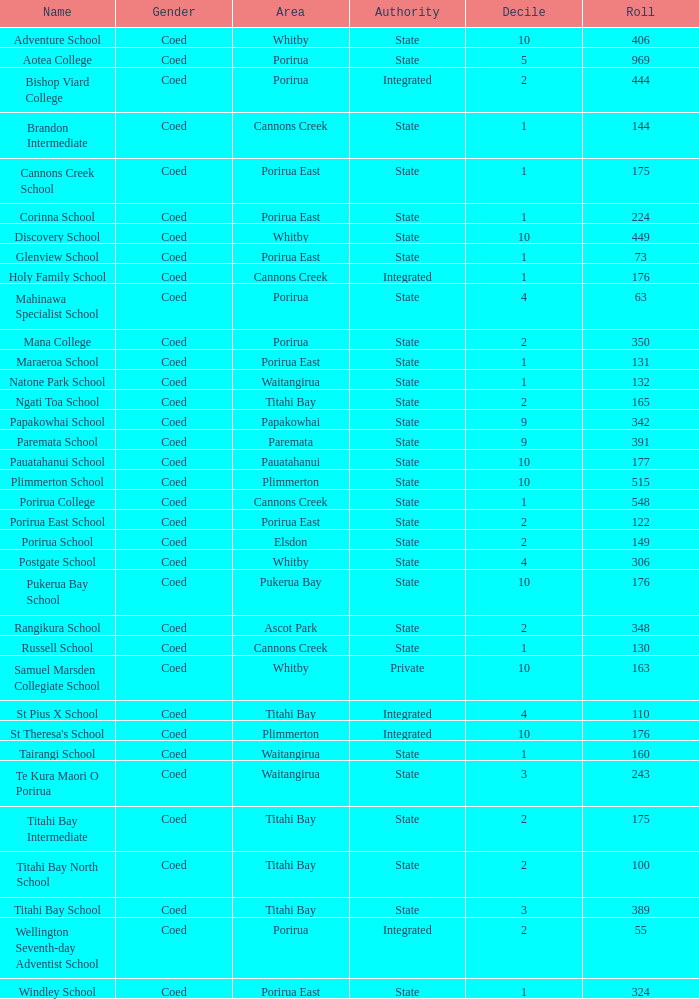Which combined school had a decile rating of 2 and an enrollment of over 55 students? Bishop Viard College. Could you help me parse every detail presented in this table? {'header': ['Name', 'Gender', 'Area', 'Authority', 'Decile', 'Roll'], 'rows': [['Adventure School', 'Coed', 'Whitby', 'State', '10', '406'], ['Aotea College', 'Coed', 'Porirua', 'State', '5', '969'], ['Bishop Viard College', 'Coed', 'Porirua', 'Integrated', '2', '444'], ['Brandon Intermediate', 'Coed', 'Cannons Creek', 'State', '1', '144'], ['Cannons Creek School', 'Coed', 'Porirua East', 'State', '1', '175'], ['Corinna School', 'Coed', 'Porirua East', 'State', '1', '224'], ['Discovery School', 'Coed', 'Whitby', 'State', '10', '449'], ['Glenview School', 'Coed', 'Porirua East', 'State', '1', '73'], ['Holy Family School', 'Coed', 'Cannons Creek', 'Integrated', '1', '176'], ['Mahinawa Specialist School', 'Coed', 'Porirua', 'State', '4', '63'], ['Mana College', 'Coed', 'Porirua', 'State', '2', '350'], ['Maraeroa School', 'Coed', 'Porirua East', 'State', '1', '131'], ['Natone Park School', 'Coed', 'Waitangirua', 'State', '1', '132'], ['Ngati Toa School', 'Coed', 'Titahi Bay', 'State', '2', '165'], ['Papakowhai School', 'Coed', 'Papakowhai', 'State', '9', '342'], ['Paremata School', 'Coed', 'Paremata', 'State', '9', '391'], ['Pauatahanui School', 'Coed', 'Pauatahanui', 'State', '10', '177'], ['Plimmerton School', 'Coed', 'Plimmerton', 'State', '10', '515'], ['Porirua College', 'Coed', 'Cannons Creek', 'State', '1', '548'], ['Porirua East School', 'Coed', 'Porirua East', 'State', '2', '122'], ['Porirua School', 'Coed', 'Elsdon', 'State', '2', '149'], ['Postgate School', 'Coed', 'Whitby', 'State', '4', '306'], ['Pukerua Bay School', 'Coed', 'Pukerua Bay', 'State', '10', '176'], ['Rangikura School', 'Coed', 'Ascot Park', 'State', '2', '348'], ['Russell School', 'Coed', 'Cannons Creek', 'State', '1', '130'], ['Samuel Marsden Collegiate School', 'Coed', 'Whitby', 'Private', '10', '163'], ['St Pius X School', 'Coed', 'Titahi Bay', 'Integrated', '4', '110'], ["St Theresa's School", 'Coed', 'Plimmerton', 'Integrated', '10', '176'], ['Tairangi School', 'Coed', 'Waitangirua', 'State', '1', '160'], ['Te Kura Maori O Porirua', 'Coed', 'Waitangirua', 'State', '3', '243'], ['Titahi Bay Intermediate', 'Coed', 'Titahi Bay', 'State', '2', '175'], ['Titahi Bay North School', 'Coed', 'Titahi Bay', 'State', '2', '100'], ['Titahi Bay School', 'Coed', 'Titahi Bay', 'State', '3', '389'], ['Wellington Seventh-day Adventist School', 'Coed', 'Porirua', 'Integrated', '2', '55'], ['Windley School', 'Coed', 'Porirua East', 'State', '1', '324']]} 